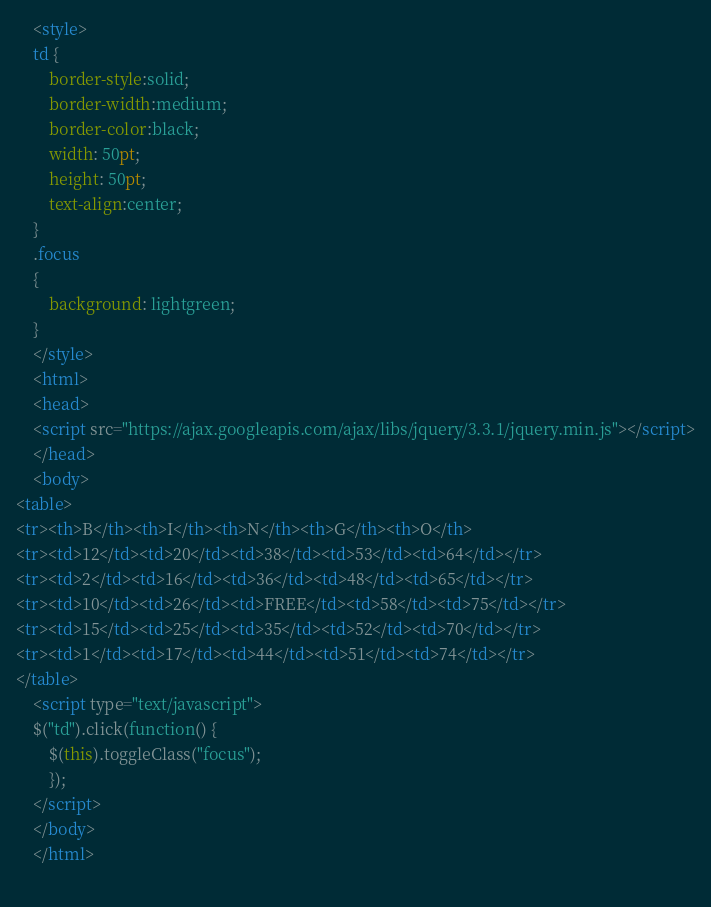Convert code to text. <code><loc_0><loc_0><loc_500><loc_500><_HTML_>
    <style>
    td {
        border-style:solid;
        border-width:medium;
        border-color:black;
        width: 50pt;
        height: 50pt;
        text-align:center;
    }
    .focus
    {
        background: lightgreen;
    }
    </style>
    <html>
    <head>
    <script src="https://ajax.googleapis.com/ajax/libs/jquery/3.3.1/jquery.min.js"></script>
    </head>
    <body>
<table>
<tr><th>B</th><th>I</th><th>N</th><th>G</th><th>O</th>
<tr><td>12</td><td>20</td><td>38</td><td>53</td><td>64</td></tr>
<tr><td>2</td><td>16</td><td>36</td><td>48</td><td>65</td></tr>
<tr><td>10</td><td>26</td><td>FREE</td><td>58</td><td>75</td></tr>
<tr><td>15</td><td>25</td><td>35</td><td>52</td><td>70</td></tr>
<tr><td>1</td><td>17</td><td>44</td><td>51</td><td>74</td></tr>
</table>
    <script type="text/javascript">
    $("td").click(function() {
        $(this).toggleClass("focus");
        });
    </script>
    </body>
    </html>
    </code> 